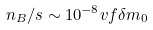<formula> <loc_0><loc_0><loc_500><loc_500>n _ { B } / s \sim 1 0 ^ { - 8 } v f \delta m _ { 0 }</formula> 